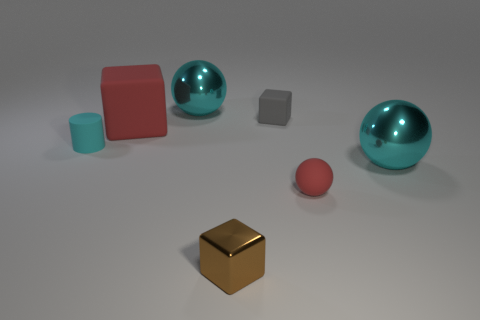There is a cyan object that is to the left of the tiny gray rubber thing and in front of the gray thing; what shape is it?
Provide a succinct answer. Cylinder. The other tiny metal object that is the same shape as the tiny gray object is what color?
Provide a succinct answer. Brown. Is there any other thing of the same color as the tiny matte cube?
Provide a short and direct response. No. Are there any large objects of the same shape as the tiny brown thing?
Your response must be concise. Yes. There is a thing that is the same color as the large block; what is it made of?
Your answer should be compact. Rubber. Do the cyan shiny thing left of the tiny brown metallic object and the tiny red object have the same shape?
Make the answer very short. Yes. How many objects are either rubber cylinders or large red rubber things?
Offer a very short reply. 2. Do the big object behind the small rubber cube and the gray object have the same material?
Give a very brief answer. No. How big is the red matte block?
Provide a succinct answer. Large. There is a small matte object that is the same color as the large matte thing; what shape is it?
Keep it short and to the point. Sphere. 